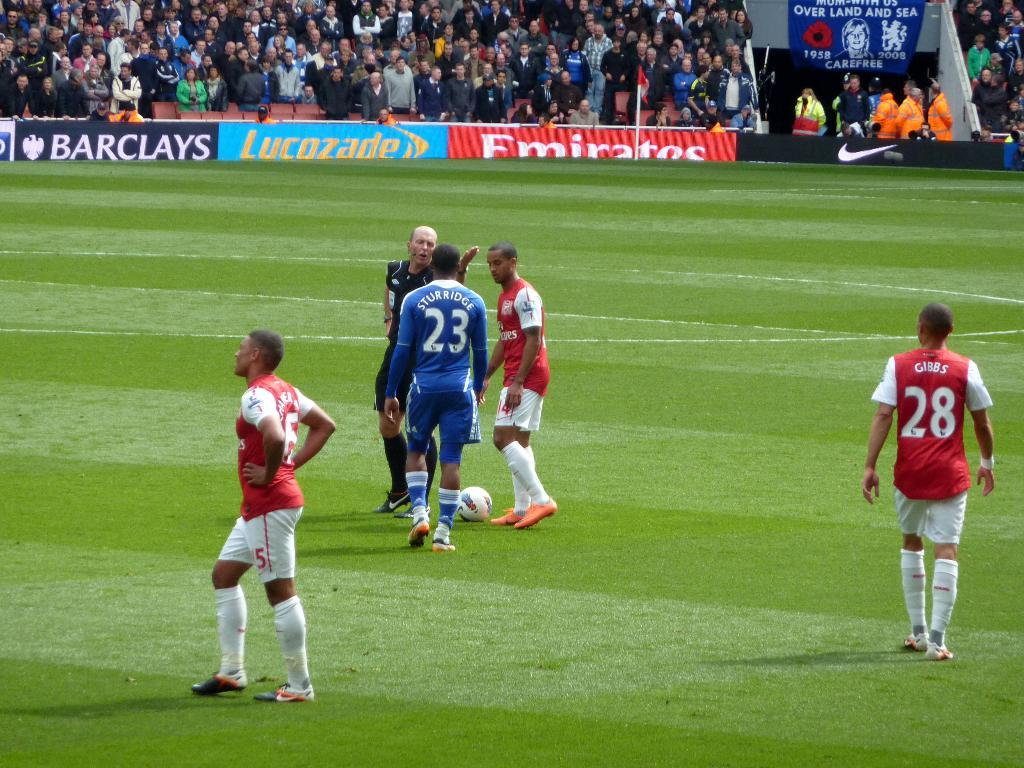<image>
Offer a succinct explanation of the picture presented. A referee gives players instructions as player number 28 in red looks on. 